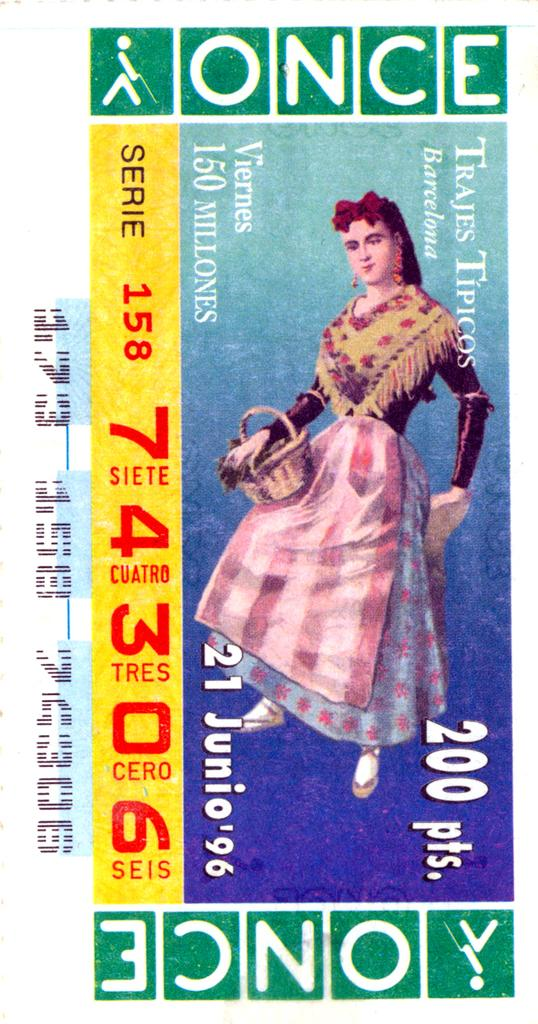What is the main subject of the image? The main subject of the image is a woman's photo. What other elements can be seen in the image? There are numbers and text in the image. How does the image appear based on the provided facts? The image resembles a lottery ticket. What scent can be detected from the image? There is no scent associated with the image, as it is a visual representation and does not have a smell. 